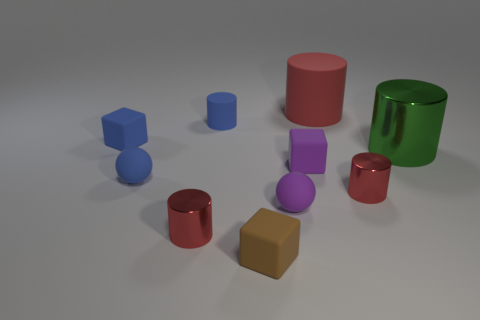Does the tiny brown matte thing have the same shape as the green metallic object?
Provide a succinct answer. No. What number of things are small objects on the left side of the big red thing or red matte cylinders?
Ensure brevity in your answer.  8. Are there any other rubber objects that have the same shape as the brown rubber object?
Make the answer very short. Yes. Is the number of small blue cylinders in front of the brown object the same as the number of tiny cyan metallic cylinders?
Make the answer very short. Yes. What number of blue matte blocks are the same size as the purple rubber cube?
Keep it short and to the point. 1. What number of tiny cylinders are behind the large green shiny cylinder?
Your answer should be compact. 1. What material is the small blue object that is to the right of the tiny ball that is on the left side of the tiny brown cube made of?
Your answer should be compact. Rubber. Are there any rubber balls of the same color as the small matte cylinder?
Your answer should be compact. Yes. There is a purple ball that is made of the same material as the large red cylinder; what size is it?
Provide a short and direct response. Small. Are there any other things of the same color as the big rubber cylinder?
Provide a succinct answer. Yes. 